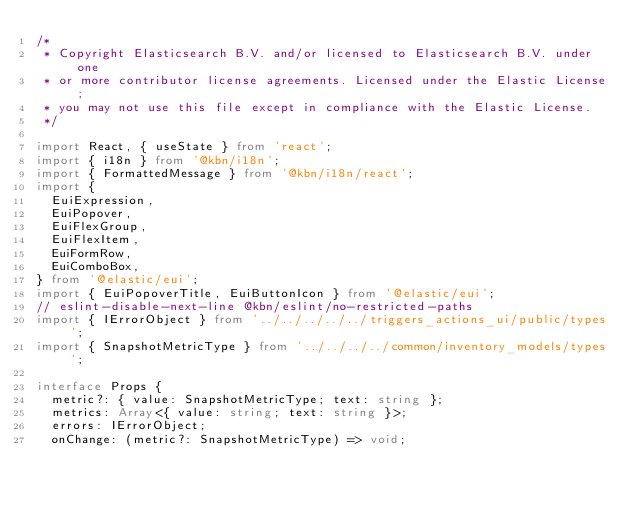Convert code to text. <code><loc_0><loc_0><loc_500><loc_500><_TypeScript_>/*
 * Copyright Elasticsearch B.V. and/or licensed to Elasticsearch B.V. under one
 * or more contributor license agreements. Licensed under the Elastic License;
 * you may not use this file except in compliance with the Elastic License.
 */

import React, { useState } from 'react';
import { i18n } from '@kbn/i18n';
import { FormattedMessage } from '@kbn/i18n/react';
import {
  EuiExpression,
  EuiPopover,
  EuiFlexGroup,
  EuiFlexItem,
  EuiFormRow,
  EuiComboBox,
} from '@elastic/eui';
import { EuiPopoverTitle, EuiButtonIcon } from '@elastic/eui';
// eslint-disable-next-line @kbn/eslint/no-restricted-paths
import { IErrorObject } from '../../../../../triggers_actions_ui/public/types';
import { SnapshotMetricType } from '../../../../common/inventory_models/types';

interface Props {
  metric?: { value: SnapshotMetricType; text: string };
  metrics: Array<{ value: string; text: string }>;
  errors: IErrorObject;
  onChange: (metric?: SnapshotMetricType) => void;</code> 